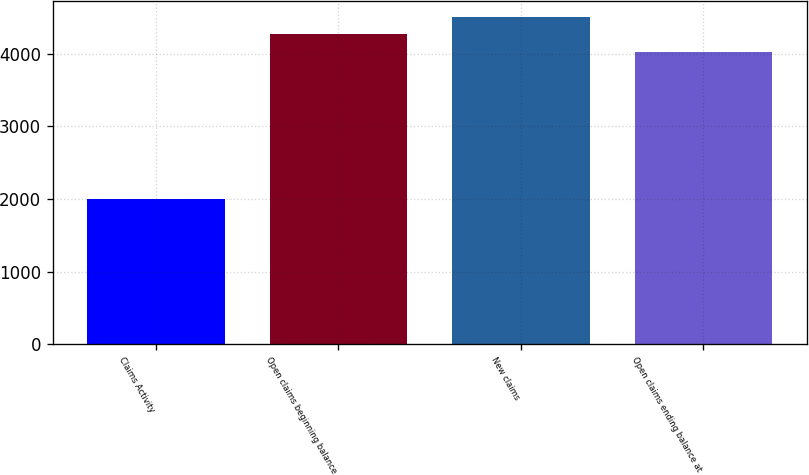<chart> <loc_0><loc_0><loc_500><loc_500><bar_chart><fcel>Claims Activity<fcel>Open claims beginning balance<fcel>New claims<fcel>Open claims ending balance at<nl><fcel>2004<fcel>4264.2<fcel>4500.4<fcel>4028<nl></chart> 